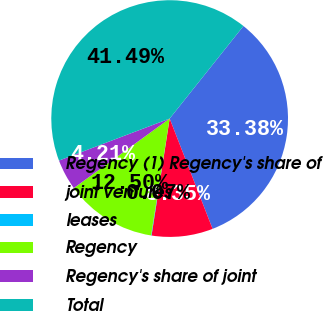Convert chart. <chart><loc_0><loc_0><loc_500><loc_500><pie_chart><fcel>Regency (1) Regency's share of<fcel>joint ventures<fcel>leases<fcel>Regency<fcel>Regency's share of joint<fcel>Total<nl><fcel>33.38%<fcel>8.35%<fcel>0.07%<fcel>12.5%<fcel>4.21%<fcel>41.49%<nl></chart> 